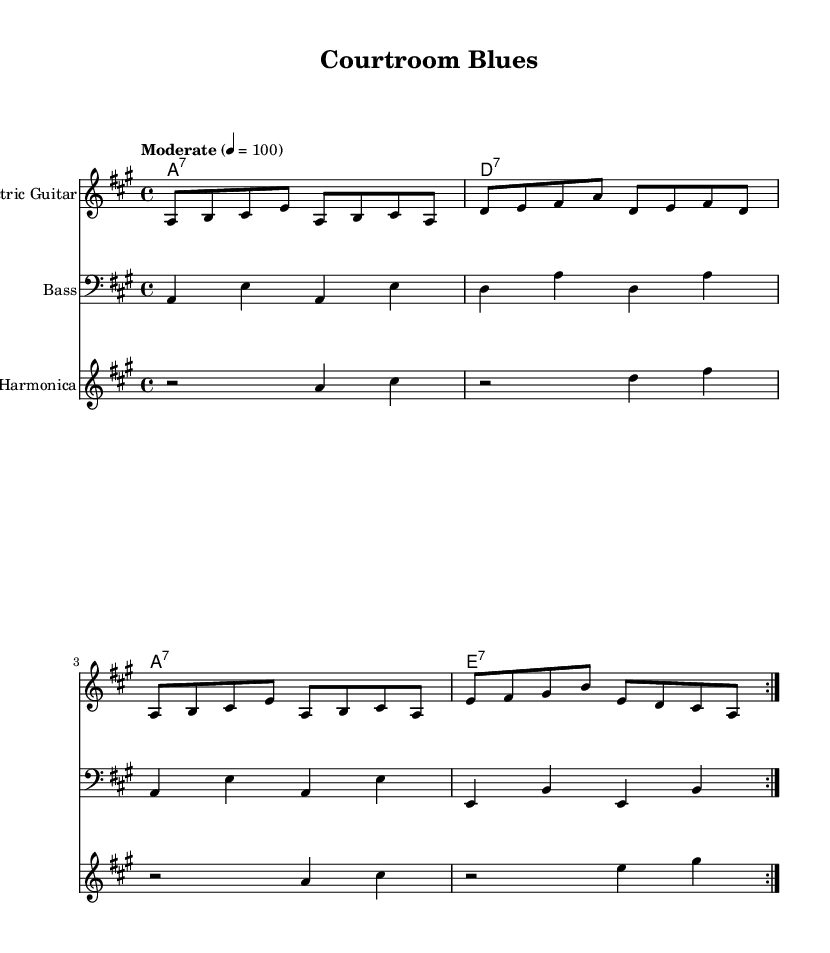What is the title of this music? The title is found in the header section of the sheet music and is explicitly stated as "Courtroom Blues".
Answer: Courtroom Blues What is the key signature of this music? The key signature is indicated by the 'a' note in the global context, which means it is in A major, identifiable by three sharps (F#, C#, and G#).
Answer: A major What is the time signature of this music? The time signature is shown as "4/4" in the global context, which indicates that there are four beats per measure with a quarter note receiving one beat.
Answer: 4/4 What is the tempo marking of this music? The tempo is set at "Moderate" with a tempo mark of 4 = 100, indicating the beats per minute.
Answer: Moderate 4 = 100 How many measures are repeated in the electric guitar part? The electric guitar part has a repeat indication (volta) that shows it is meant to be played two times through the specified measures.
Answer: 2 What is the chord progression used in this piece? The chord progression can be found in the chord names section and follows a standard electric blues pattern: A7, D7, A7, E7.
Answer: A7, D7, A7, E7 What instrument is likely to carry the melody in this music? The electric guitar is positioned as the primary melodic instrument in the arrangement, typical of the Electric Blues genre, providing the leading melody lines.
Answer: Electric Guitar 